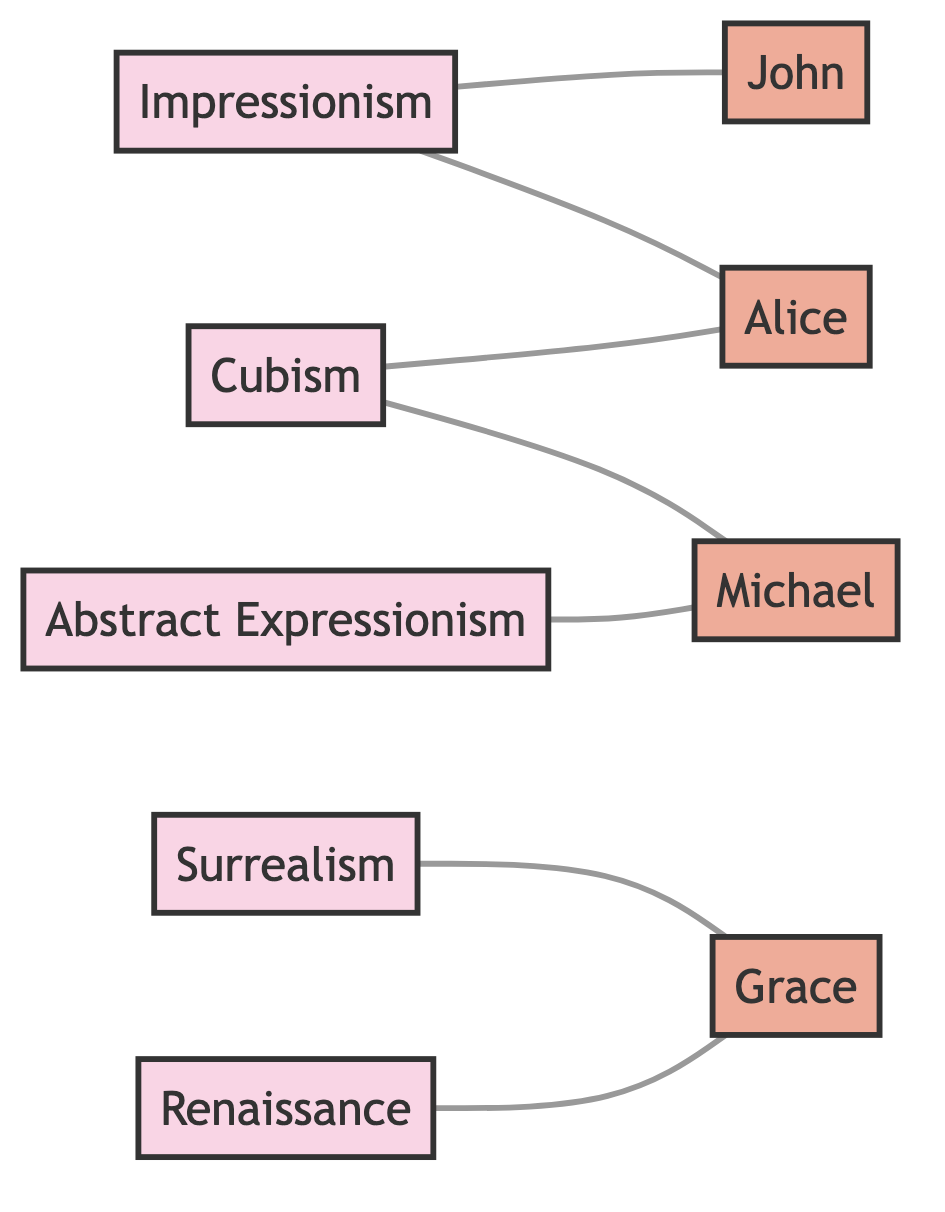What nodes represent art movements? The nodes representing art movements are Impressionism, Cubism, Surrealism, Abstract Expressionism, and Renaissance. These nodes are labeled and are distinct from the artist nodes.
Answer: Impressionism, Cubism, Surrealism, Abstract Expressionism, Renaissance How many artists are connected to Impressionism? To determine this, we look at the edges connected to the Impressionism node. It connects to two artist nodes: John and Alice. Therefore, there are two artists connected to Impressionism.
Answer: 2 Which artist is influenced by Surrealism? By examining the edges connected to the Surrealism node, we can see that it is connected to the artist node Grace. Thus, Grace is the artist influenced by Surrealism.
Answer: Grace How many edges are there in total? The edges listed in the diagram are: Impressionism to John, Cubism to Alice, Surrealism to Grace, Abstract Expressionism to Michael, Renaissance to Grace, Impressionism to Alice, and Cubism to Michael. Counting these, there are a total of seven edges.
Answer: 7 Which two artists are influenced by Cubism? Checking the edges connected to the Cubism node reveals that it connects to Alice and Michael. Therefore, both Alice and Michael are the artists influenced by Cubism.
Answer: Alice, Michael Which art movement influences Grace? Grace is influenced by two art movements: Surrealism and Renaissance. We can identify this by looking at the connections from the respective art movement nodes to the artist node Grace.
Answer: Surrealism, Renaissance Is there any artist influenced by both Impressionism and Cubism? To find this, we look for an artist that has edges connecting to both the Impressionism and Cubism nodes. Alice fits this criterion as she is connected to both movements, thus making her the answer.
Answer: Alice 